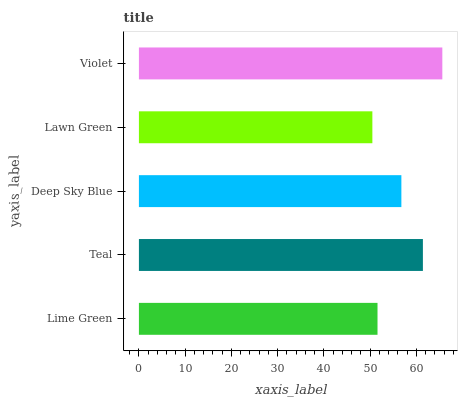Is Lawn Green the minimum?
Answer yes or no. Yes. Is Violet the maximum?
Answer yes or no. Yes. Is Teal the minimum?
Answer yes or no. No. Is Teal the maximum?
Answer yes or no. No. Is Teal greater than Lime Green?
Answer yes or no. Yes. Is Lime Green less than Teal?
Answer yes or no. Yes. Is Lime Green greater than Teal?
Answer yes or no. No. Is Teal less than Lime Green?
Answer yes or no. No. Is Deep Sky Blue the high median?
Answer yes or no. Yes. Is Deep Sky Blue the low median?
Answer yes or no. Yes. Is Violet the high median?
Answer yes or no. No. Is Lawn Green the low median?
Answer yes or no. No. 